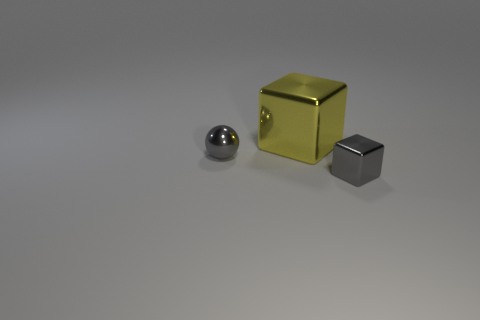Subtract all yellow blocks. How many blocks are left? 1 Subtract 1 spheres. How many spheres are left? 0 Subtract all big yellow metallic objects. Subtract all large red shiny cylinders. How many objects are left? 2 Add 2 tiny cubes. How many tiny cubes are left? 3 Add 3 small yellow metallic things. How many small yellow metallic things exist? 3 Add 2 yellow metallic things. How many objects exist? 5 Subtract 0 purple blocks. How many objects are left? 3 Subtract all blocks. How many objects are left? 1 Subtract all yellow spheres. Subtract all gray cylinders. How many spheres are left? 1 Subtract all purple spheres. How many yellow blocks are left? 1 